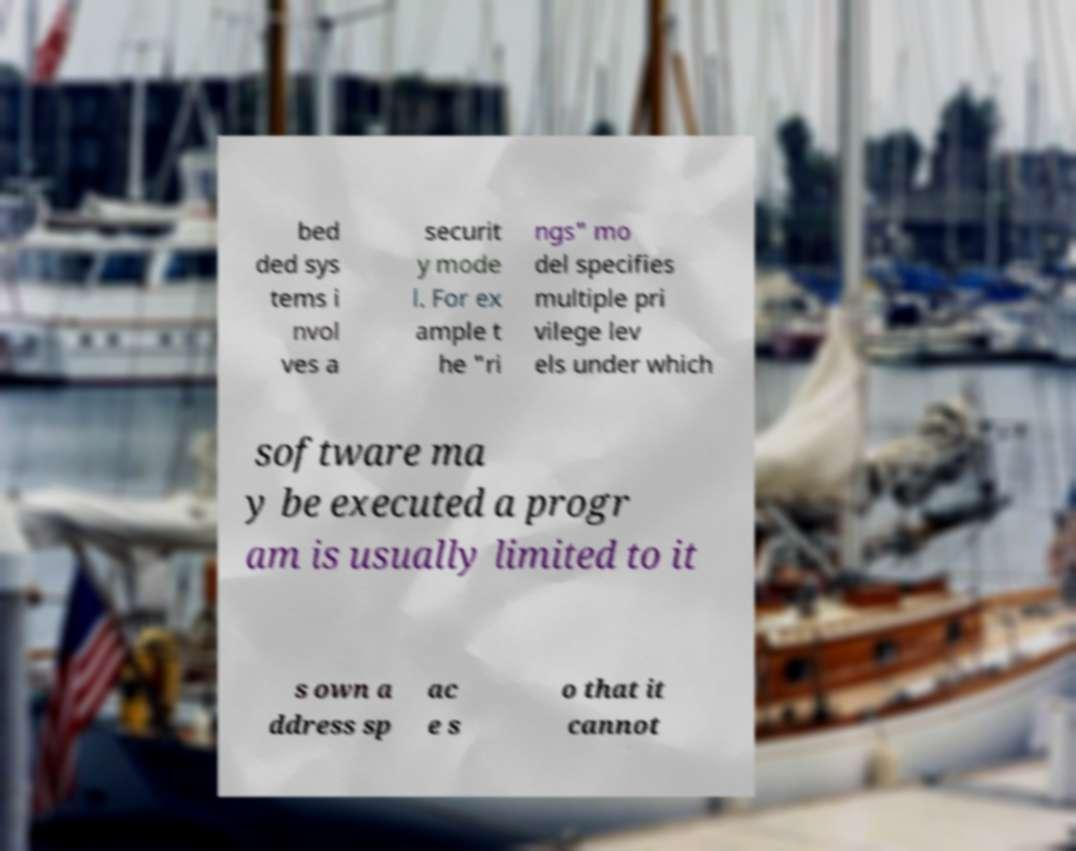Please identify and transcribe the text found in this image. bed ded sys tems i nvol ves a securit y mode l. For ex ample t he "ri ngs" mo del specifies multiple pri vilege lev els under which software ma y be executed a progr am is usually limited to it s own a ddress sp ac e s o that it cannot 